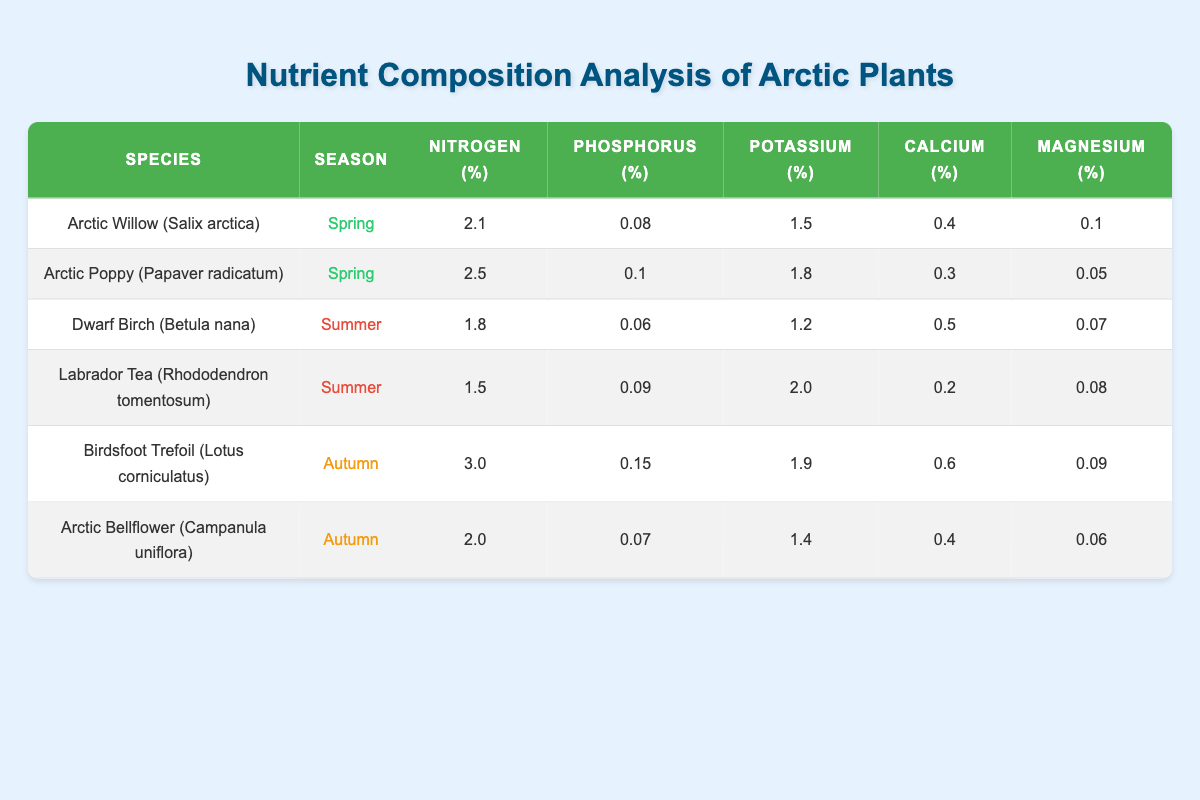What are the nitrogen levels of Arctic Willow (Salix arctica) in Spring? The nitrogen level for Arctic Willow (Salix arctica) in Spring is listed directly in the table under the 'Nitrogen (%)' column. The corresponding value is 2.1%.
Answer: 2.1% Which species has the highest potassium content in Summer? The table shows that Dwarf Birch (Betula nana) has a potassium level of 1.2% and Labrador Tea (Rhododendron tomentosum) has a potassium level of 2.0% in Summer. Comparing these values, the highest is from Labrador Tea.
Answer: Labrador Tea (Rhododendron tomentosum) Is the phosphorus content of Arctic Poppy (Papaver radicatum) higher than that of Arctic Bellflower (Campanula uniflora) in Autumn? Arctic Poppy has a phosphorus content of 0.1%, while Arctic Bellflower has a phosphorus content of 0.07% listed under their respective seasons. Since 0.1% is greater than 0.07%, the statement is true.
Answer: Yes What is the average calcium content for the four species included in both Spring and Summer? First, identify the calcium levels: Arctic Willow (0.4%), Arctic Poppy (0.3%), Dwarf Birch (0.5%), and Labrador Tea (0.2%). Adding these values gives a total of 0.4 + 0.3 + 0.5 + 0.2 = 1.4%. There are four values, so the average is calculated as 1.4% / 4 = 0.35%.
Answer: 0.35% Which species has the lowest magnesium content in the table? The magnesium content needs to be compared for all species: Arctic Willow (0.1%), Arctic Poppy (0.05%), Dwarf Birch (0.07%), Labrador Tea (0.08%), Birdsfoot Trefoil (0.09%), Arctic Bellflower (0.06%). The lowest value is 0.05% for Arctic Poppy.
Answer: Arctic Poppy (Papaver radicatum) 